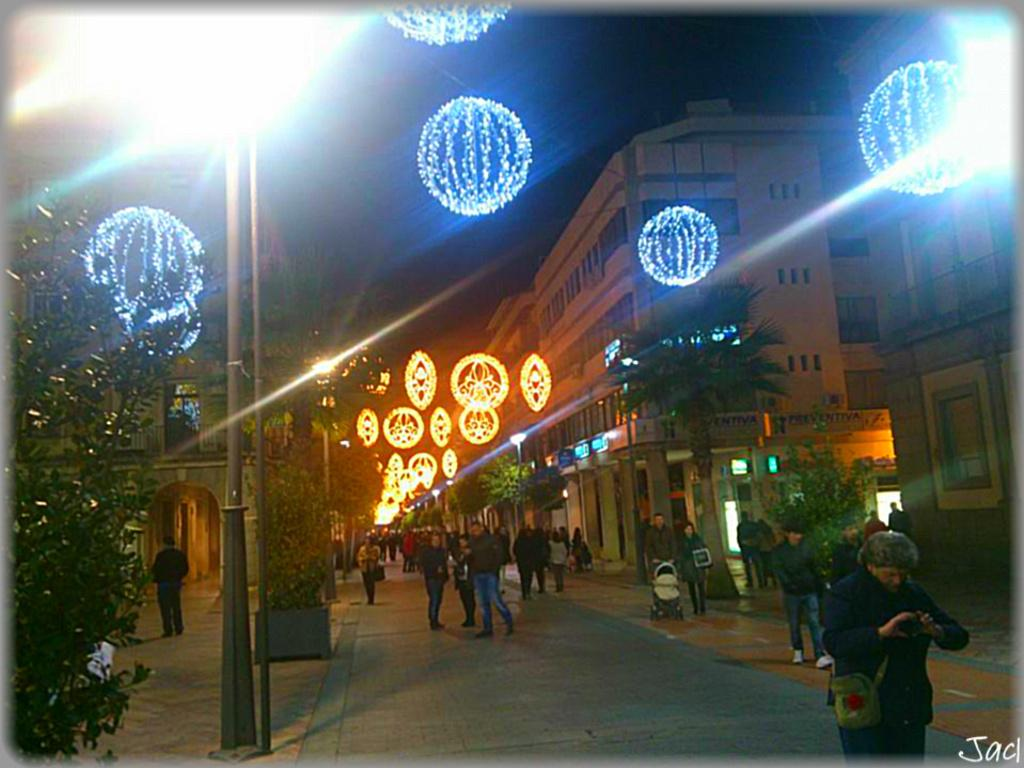Who or what can be seen in the image? There are people in the image. What type of natural elements are present in the image? There are trees in the image. What additional decorative elements can be seen in the image? Decorative lights are visible at the top of the image. What can be seen in the distance in the image? There are buildings and poles in the background of the image. What part of the natural environment is visible in the image? The sky is visible in the background of the image. Can you tell me how many basketballs are being played with in the image? There are no basketballs or basketball games visible in the image. 